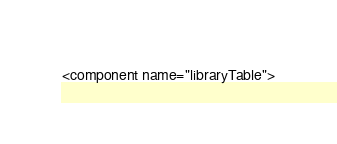<code> <loc_0><loc_0><loc_500><loc_500><_XML_><component name="libraryTable"></code> 